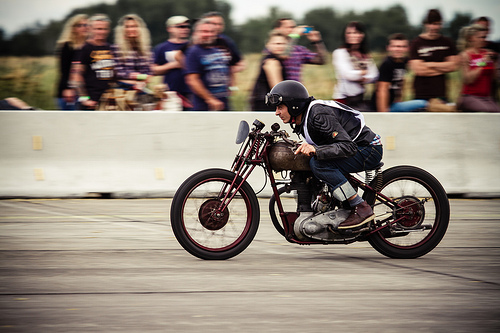<image>
Can you confirm if the bike is on the road? Yes. Looking at the image, I can see the bike is positioned on top of the road, with the road providing support. Is there a wall to the right of the bike? Yes. From this viewpoint, the wall is positioned to the right side relative to the bike. 